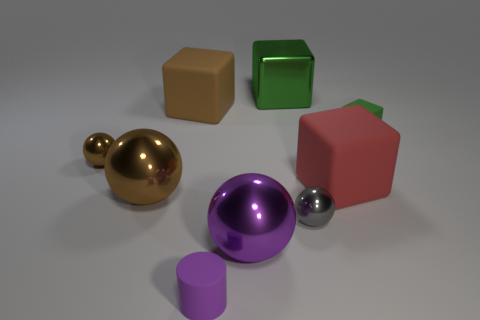Add 1 large gray metal things. How many objects exist? 10 Subtract all blocks. How many objects are left? 5 Add 3 cyan cubes. How many cyan cubes exist? 3 Subtract 0 green spheres. How many objects are left? 9 Subtract all big green metallic things. Subtract all green rubber objects. How many objects are left? 7 Add 4 big green blocks. How many big green blocks are left? 5 